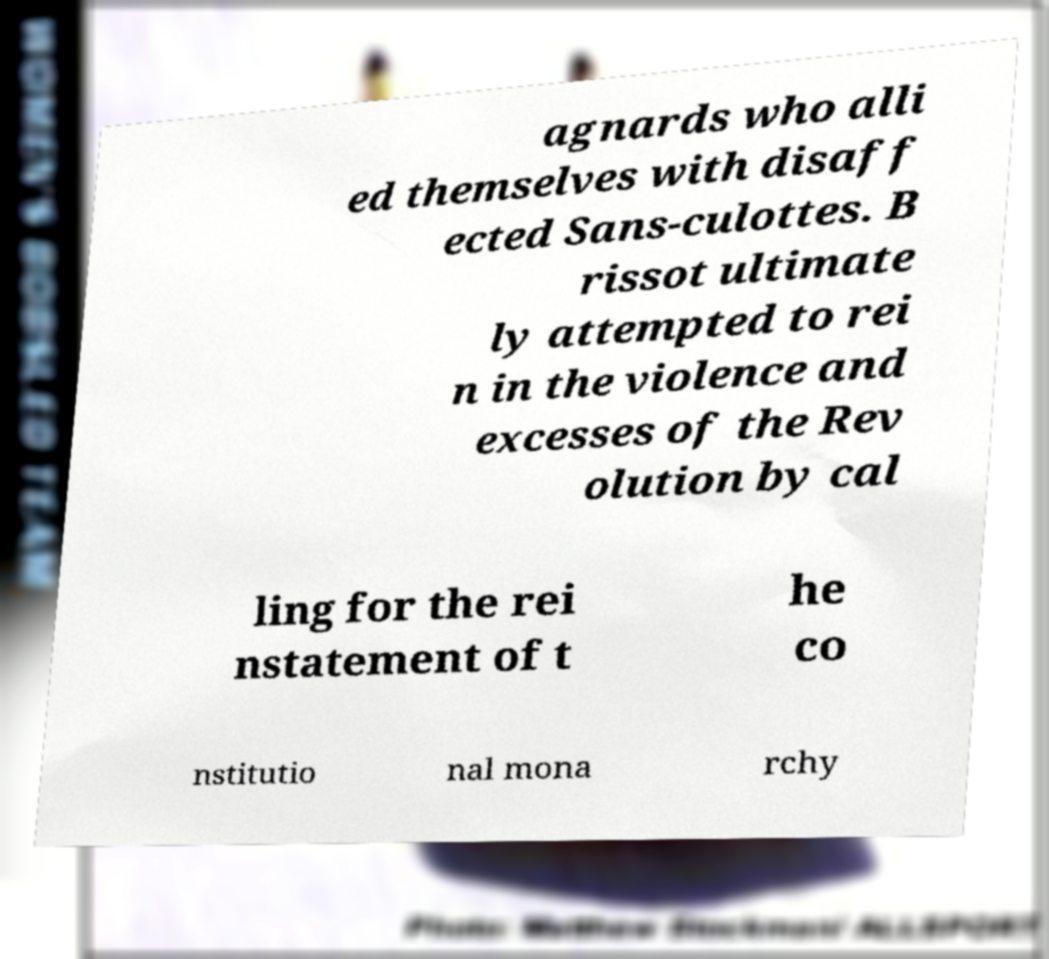I need the written content from this picture converted into text. Can you do that? agnards who alli ed themselves with disaff ected Sans-culottes. B rissot ultimate ly attempted to rei n in the violence and excesses of the Rev olution by cal ling for the rei nstatement of t he co nstitutio nal mona rchy 